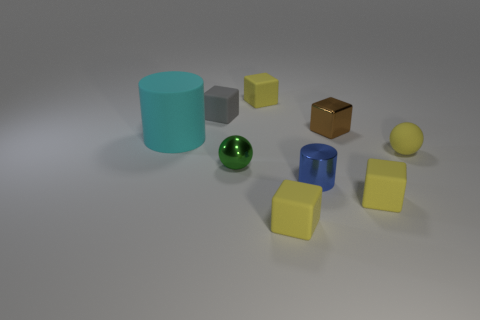What can be inferred about the lighting in the scene based on the shadows and reflections? The lighting in the scene appears to be diffused and coming from above, given the soft shadows cast by the objects. The reflections on the spheres, especially the green metal one, suggest a somewhat reflective surface above, possibly a light source. There are no sharp or dark shadows, which indicates there isn't a direct point light source very close to the objects. 